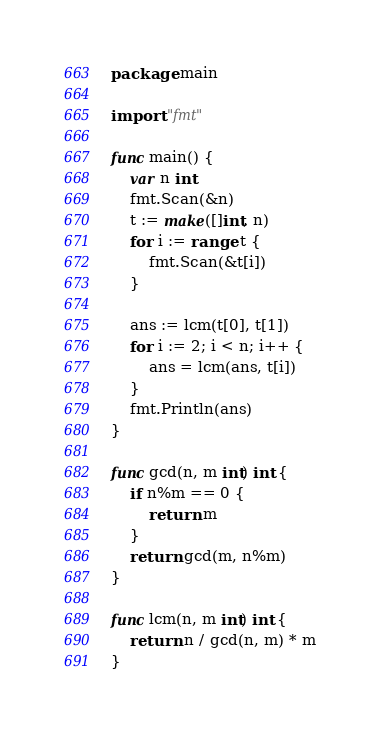<code> <loc_0><loc_0><loc_500><loc_500><_Go_>package main

import "fmt"

func main() {
	var n int
	fmt.Scan(&n)
	t := make([]int, n)
	for i := range t {
		fmt.Scan(&t[i])
	}

	ans := lcm(t[0], t[1])
	for i := 2; i < n; i++ {
		ans = lcm(ans, t[i])
	}
	fmt.Println(ans)
}

func gcd(n, m int) int {
	if n%m == 0 {
		return m
	}
	return gcd(m, n%m)
}

func lcm(n, m int) int {
	return n / gcd(n, m) * m
}
</code> 